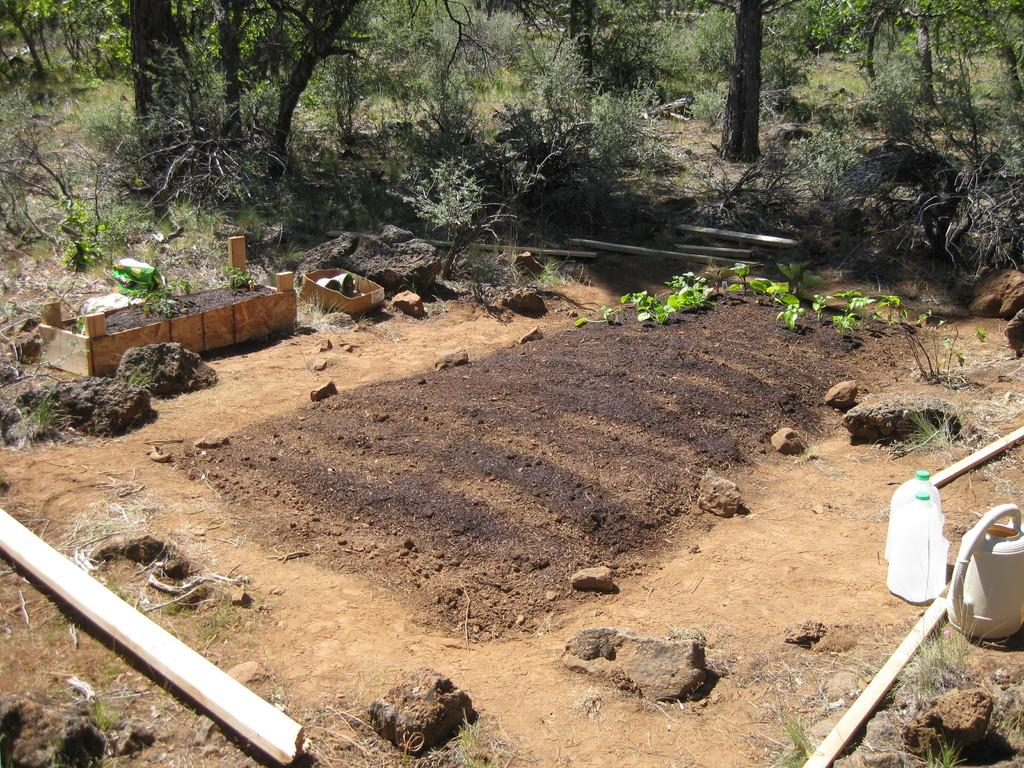What can be seen in the image that represents burial sites? There are graves in the image. What type of vegetation is visible in the background of the image? There are trees, plants, and grass in the background of the image. What objects are on the right side of the image? There are water cans on the right side of the image. What else is present beside the water cans? There are wooden sticks beside the water cans. What type of weather can be seen in the image? The image does not depict any weather conditions; it only shows graves, vegetation, and objects. 